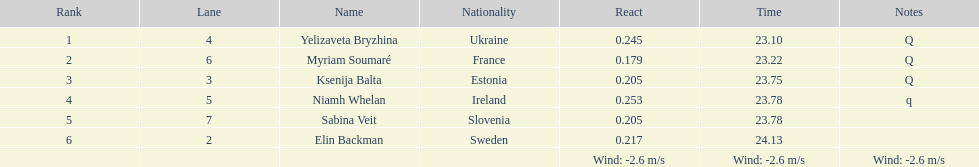Who finished after sabina veit? Elin Backman. 